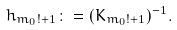Convert formula to latex. <formula><loc_0><loc_0><loc_500><loc_500>h _ { m _ { 0 } ! + 1 } \colon = ( K _ { m _ { 0 } ! + 1 } ) ^ { - 1 } .</formula> 